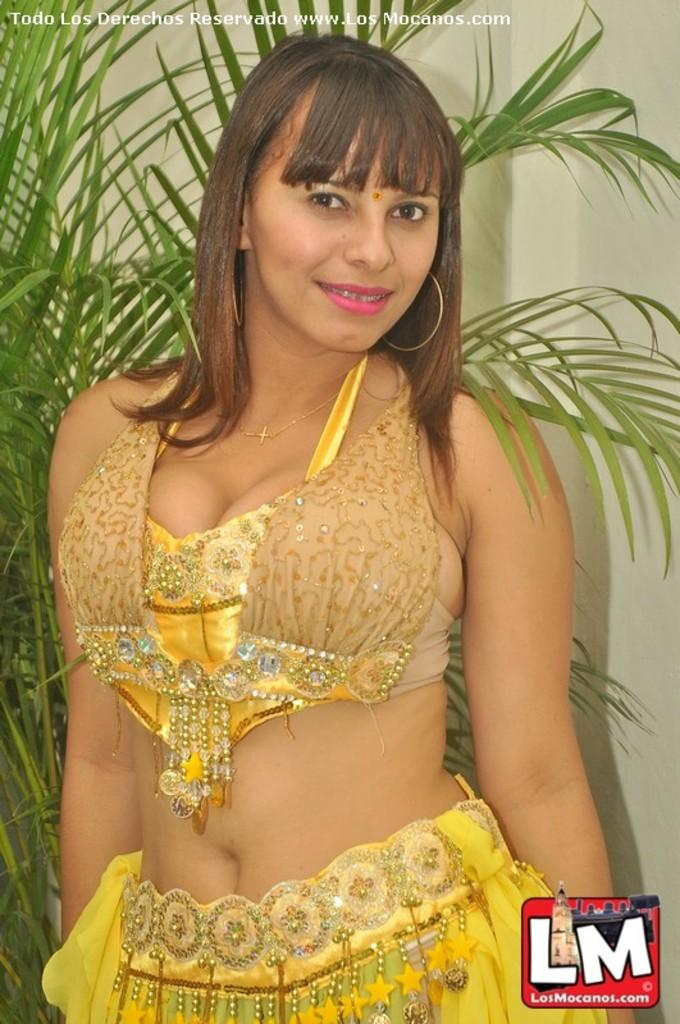Who is the main subject in the image? There is a woman in the image. What is the woman wearing? The woman is wearing a yellow dress. What is the woman doing in the image? The woman is standing and posing for a photograph. What can be seen in the background of the image? There is a plant and a wall in the background of the image. What type of ship can be seen sailing in the background of the image? There is no ship present in the image; it only features a woman, a yellow dress, and a background with a plant and a wall. 